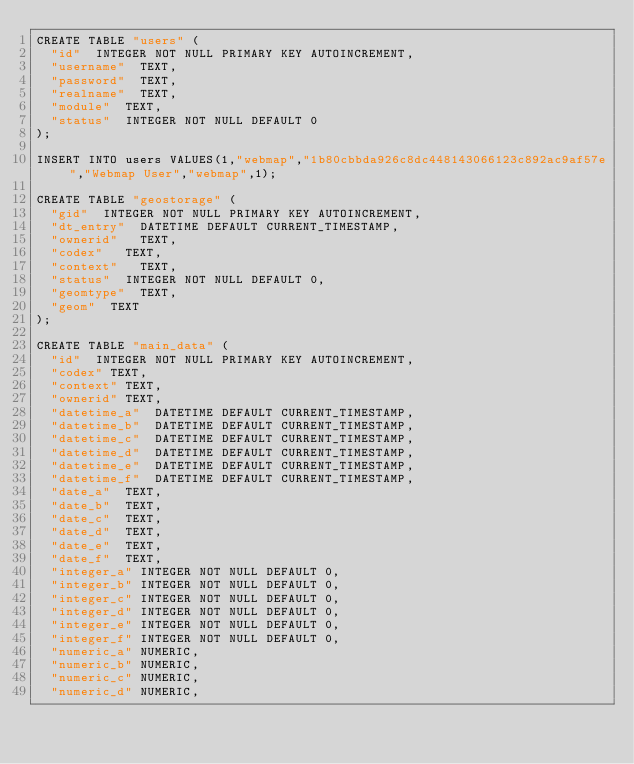<code> <loc_0><loc_0><loc_500><loc_500><_SQL_>CREATE TABLE "users" (
  "id"  INTEGER NOT NULL PRIMARY KEY AUTOINCREMENT,
  "username"  TEXT,
  "password"  TEXT,
  "realname"  TEXT,
  "module"  TEXT,
  "status"  INTEGER NOT NULL DEFAULT 0
);

INSERT INTO users VALUES(1,"webmap","1b80cbbda926c8dc448143066123c892ac9af57e","Webmap User","webmap",1);

CREATE TABLE "geostorage" (
  "gid"  INTEGER NOT NULL PRIMARY KEY AUTOINCREMENT,
  "dt_entry"  DATETIME DEFAULT CURRENT_TIMESTAMP,
  "ownerid"   TEXT,
  "codex"   TEXT,
  "context"   TEXT,
  "status"  INTEGER NOT NULL DEFAULT 0,
  "geomtype"  TEXT,
  "geom"  TEXT
);

CREATE TABLE "main_data" (
	"id"	INTEGER NOT NULL PRIMARY KEY AUTOINCREMENT,
	"codex"	TEXT,
	"context"	TEXT,
	"ownerid"	TEXT,
	"datetime_a"	DATETIME DEFAULT CURRENT_TIMESTAMP,
	"datetime_b"	DATETIME DEFAULT CURRENT_TIMESTAMP,
	"datetime_c"	DATETIME DEFAULT CURRENT_TIMESTAMP,
	"datetime_d"	DATETIME DEFAULT CURRENT_TIMESTAMP,
	"datetime_e"	DATETIME DEFAULT CURRENT_TIMESTAMP,
	"datetime_f"	DATETIME DEFAULT CURRENT_TIMESTAMP,
  "date_a"	TEXT,
  "date_b"	TEXT,
  "date_c"	TEXT,
  "date_d"	TEXT,
  "date_e"	TEXT,
  "date_f"	TEXT,
	"integer_a"	INTEGER NOT NULL DEFAULT 0,
	"integer_b"	INTEGER NOT NULL DEFAULT 0,
	"integer_c"	INTEGER NOT NULL DEFAULT 0,
	"integer_d"	INTEGER NOT NULL DEFAULT 0,
	"integer_e"	INTEGER NOT NULL DEFAULT 0,
	"integer_f"	INTEGER NOT NULL DEFAULT 0,
	"numeric_a"	NUMERIC,
	"numeric_b"	NUMERIC,
	"numeric_c"	NUMERIC,
	"numeric_d"	NUMERIC,</code> 